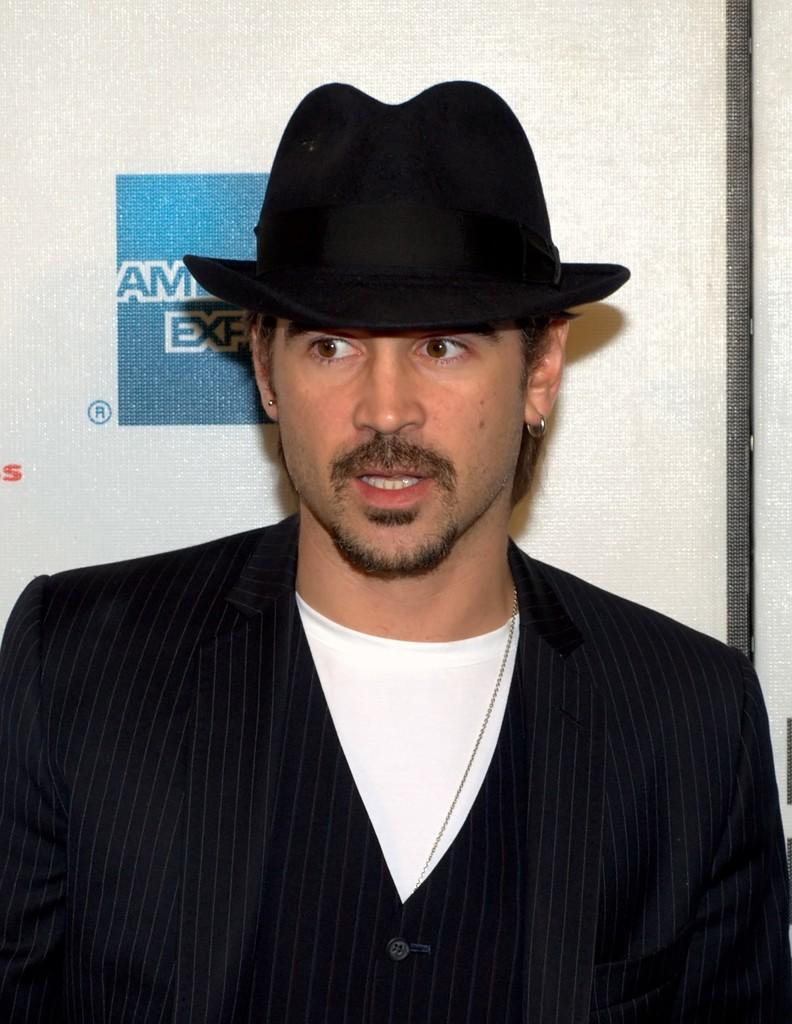Who is the main subject in the image? There is a man in the center of the image. What is the man wearing on his head? The man is wearing a hat. What type of clothing is the man wearing? The man is wearing a suit. What can be seen in the background of the image? There is a board visible in the background of the image. How many pizzas are being served by the boy in the image? There is no boy or pizzas present in the image. What type of disease is the man suffering from in the image? There is no indication of any disease in the image; the man is simply wearing a hat and suit. 